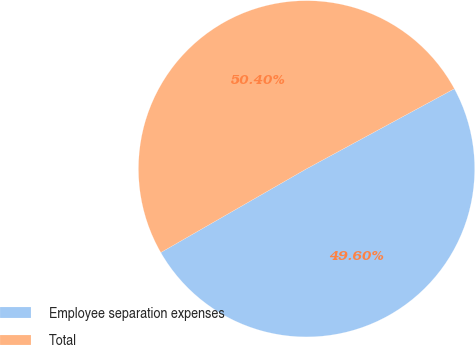Convert chart. <chart><loc_0><loc_0><loc_500><loc_500><pie_chart><fcel>Employee separation expenses<fcel>Total<nl><fcel>49.6%<fcel>50.4%<nl></chart> 